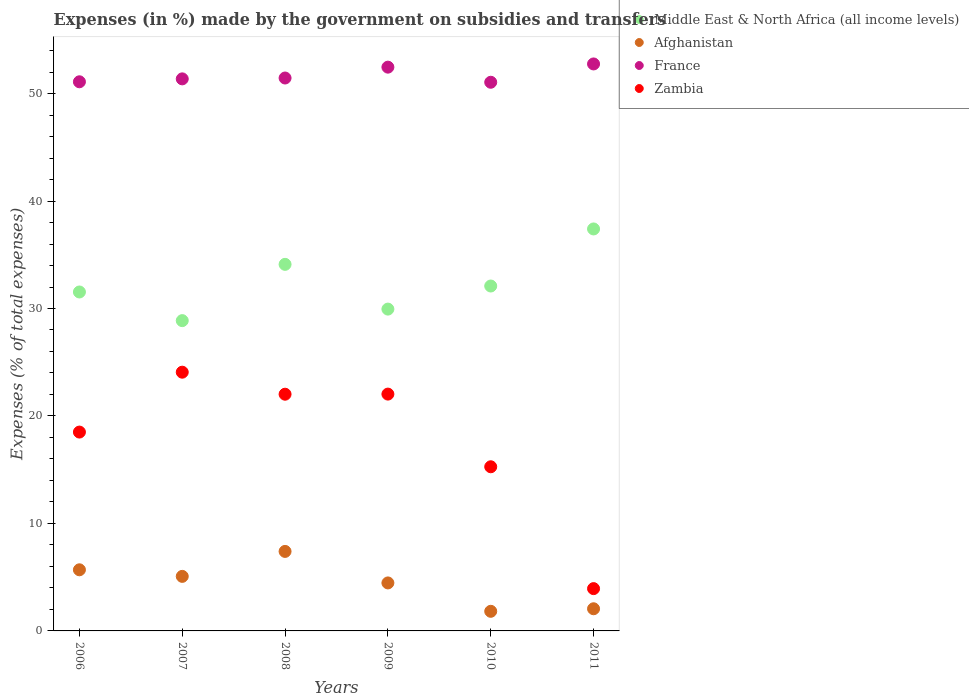How many different coloured dotlines are there?
Ensure brevity in your answer.  4. What is the percentage of expenses made by the government on subsidies and transfers in Zambia in 2008?
Your answer should be compact. 22.02. Across all years, what is the maximum percentage of expenses made by the government on subsidies and transfers in Zambia?
Offer a terse response. 24.07. Across all years, what is the minimum percentage of expenses made by the government on subsidies and transfers in Middle East & North Africa (all income levels)?
Offer a terse response. 28.87. In which year was the percentage of expenses made by the government on subsidies and transfers in Afghanistan maximum?
Provide a succinct answer. 2008. In which year was the percentage of expenses made by the government on subsidies and transfers in Zambia minimum?
Provide a short and direct response. 2011. What is the total percentage of expenses made by the government on subsidies and transfers in Middle East & North Africa (all income levels) in the graph?
Ensure brevity in your answer.  193.95. What is the difference between the percentage of expenses made by the government on subsidies and transfers in Zambia in 2006 and that in 2008?
Your answer should be compact. -3.52. What is the difference between the percentage of expenses made by the government on subsidies and transfers in Afghanistan in 2006 and the percentage of expenses made by the government on subsidies and transfers in Zambia in 2010?
Offer a terse response. -9.59. What is the average percentage of expenses made by the government on subsidies and transfers in Afghanistan per year?
Provide a short and direct response. 4.42. In the year 2006, what is the difference between the percentage of expenses made by the government on subsidies and transfers in Zambia and percentage of expenses made by the government on subsidies and transfers in France?
Make the answer very short. -32.59. What is the ratio of the percentage of expenses made by the government on subsidies and transfers in Zambia in 2009 to that in 2011?
Your answer should be compact. 5.6. Is the percentage of expenses made by the government on subsidies and transfers in Afghanistan in 2010 less than that in 2011?
Offer a very short reply. Yes. Is the difference between the percentage of expenses made by the government on subsidies and transfers in Zambia in 2006 and 2008 greater than the difference between the percentage of expenses made by the government on subsidies and transfers in France in 2006 and 2008?
Your answer should be compact. No. What is the difference between the highest and the second highest percentage of expenses made by the government on subsidies and transfers in France?
Provide a short and direct response. 0.3. What is the difference between the highest and the lowest percentage of expenses made by the government on subsidies and transfers in Afghanistan?
Offer a terse response. 5.57. Is it the case that in every year, the sum of the percentage of expenses made by the government on subsidies and transfers in Afghanistan and percentage of expenses made by the government on subsidies and transfers in France  is greater than the percentage of expenses made by the government on subsidies and transfers in Zambia?
Provide a short and direct response. Yes. Does the percentage of expenses made by the government on subsidies and transfers in Middle East & North Africa (all income levels) monotonically increase over the years?
Give a very brief answer. No. Is the percentage of expenses made by the government on subsidies and transfers in France strictly less than the percentage of expenses made by the government on subsidies and transfers in Middle East & North Africa (all income levels) over the years?
Provide a short and direct response. No. How many dotlines are there?
Your answer should be compact. 4. What is the difference between two consecutive major ticks on the Y-axis?
Offer a very short reply. 10. Are the values on the major ticks of Y-axis written in scientific E-notation?
Your answer should be very brief. No. Where does the legend appear in the graph?
Keep it short and to the point. Top right. How are the legend labels stacked?
Keep it short and to the point. Vertical. What is the title of the graph?
Offer a terse response. Expenses (in %) made by the government on subsidies and transfers. Does "Liberia" appear as one of the legend labels in the graph?
Your answer should be very brief. No. What is the label or title of the X-axis?
Your response must be concise. Years. What is the label or title of the Y-axis?
Your answer should be very brief. Expenses (% of total expenses). What is the Expenses (% of total expenses) in Middle East & North Africa (all income levels) in 2006?
Your answer should be very brief. 31.54. What is the Expenses (% of total expenses) of Afghanistan in 2006?
Keep it short and to the point. 5.69. What is the Expenses (% of total expenses) in France in 2006?
Provide a short and direct response. 51.09. What is the Expenses (% of total expenses) of Zambia in 2006?
Make the answer very short. 18.5. What is the Expenses (% of total expenses) in Middle East & North Africa (all income levels) in 2007?
Provide a short and direct response. 28.87. What is the Expenses (% of total expenses) in Afghanistan in 2007?
Provide a succinct answer. 5.08. What is the Expenses (% of total expenses) of France in 2007?
Your response must be concise. 51.37. What is the Expenses (% of total expenses) of Zambia in 2007?
Provide a short and direct response. 24.07. What is the Expenses (% of total expenses) in Middle East & North Africa (all income levels) in 2008?
Your answer should be compact. 34.11. What is the Expenses (% of total expenses) in Afghanistan in 2008?
Your answer should be very brief. 7.4. What is the Expenses (% of total expenses) of France in 2008?
Offer a very short reply. 51.45. What is the Expenses (% of total expenses) in Zambia in 2008?
Offer a very short reply. 22.02. What is the Expenses (% of total expenses) of Middle East & North Africa (all income levels) in 2009?
Give a very brief answer. 29.94. What is the Expenses (% of total expenses) in Afghanistan in 2009?
Make the answer very short. 4.47. What is the Expenses (% of total expenses) in France in 2009?
Provide a succinct answer. 52.46. What is the Expenses (% of total expenses) in Zambia in 2009?
Provide a short and direct response. 22.04. What is the Expenses (% of total expenses) of Middle East & North Africa (all income levels) in 2010?
Your answer should be compact. 32.09. What is the Expenses (% of total expenses) of Afghanistan in 2010?
Offer a very short reply. 1.82. What is the Expenses (% of total expenses) of France in 2010?
Your response must be concise. 51.05. What is the Expenses (% of total expenses) in Zambia in 2010?
Make the answer very short. 15.27. What is the Expenses (% of total expenses) in Middle East & North Africa (all income levels) in 2011?
Your response must be concise. 37.4. What is the Expenses (% of total expenses) in Afghanistan in 2011?
Offer a very short reply. 2.06. What is the Expenses (% of total expenses) of France in 2011?
Offer a terse response. 52.75. What is the Expenses (% of total expenses) in Zambia in 2011?
Offer a terse response. 3.94. Across all years, what is the maximum Expenses (% of total expenses) of Middle East & North Africa (all income levels)?
Make the answer very short. 37.4. Across all years, what is the maximum Expenses (% of total expenses) in Afghanistan?
Provide a short and direct response. 7.4. Across all years, what is the maximum Expenses (% of total expenses) of France?
Give a very brief answer. 52.75. Across all years, what is the maximum Expenses (% of total expenses) in Zambia?
Offer a terse response. 24.07. Across all years, what is the minimum Expenses (% of total expenses) in Middle East & North Africa (all income levels)?
Your response must be concise. 28.87. Across all years, what is the minimum Expenses (% of total expenses) of Afghanistan?
Offer a very short reply. 1.82. Across all years, what is the minimum Expenses (% of total expenses) in France?
Keep it short and to the point. 51.05. Across all years, what is the minimum Expenses (% of total expenses) of Zambia?
Your answer should be very brief. 3.94. What is the total Expenses (% of total expenses) in Middle East & North Africa (all income levels) in the graph?
Your response must be concise. 193.95. What is the total Expenses (% of total expenses) in Afghanistan in the graph?
Your answer should be compact. 26.51. What is the total Expenses (% of total expenses) in France in the graph?
Offer a terse response. 310.17. What is the total Expenses (% of total expenses) in Zambia in the graph?
Provide a succinct answer. 105.84. What is the difference between the Expenses (% of total expenses) in Middle East & North Africa (all income levels) in 2006 and that in 2007?
Make the answer very short. 2.67. What is the difference between the Expenses (% of total expenses) of Afghanistan in 2006 and that in 2007?
Offer a very short reply. 0.61. What is the difference between the Expenses (% of total expenses) in France in 2006 and that in 2007?
Your answer should be compact. -0.27. What is the difference between the Expenses (% of total expenses) in Zambia in 2006 and that in 2007?
Make the answer very short. -5.57. What is the difference between the Expenses (% of total expenses) in Middle East & North Africa (all income levels) in 2006 and that in 2008?
Provide a short and direct response. -2.57. What is the difference between the Expenses (% of total expenses) in Afghanistan in 2006 and that in 2008?
Provide a succinct answer. -1.71. What is the difference between the Expenses (% of total expenses) in France in 2006 and that in 2008?
Your answer should be compact. -0.35. What is the difference between the Expenses (% of total expenses) of Zambia in 2006 and that in 2008?
Offer a terse response. -3.52. What is the difference between the Expenses (% of total expenses) in Middle East & North Africa (all income levels) in 2006 and that in 2009?
Provide a short and direct response. 1.59. What is the difference between the Expenses (% of total expenses) of Afghanistan in 2006 and that in 2009?
Your response must be concise. 1.22. What is the difference between the Expenses (% of total expenses) of France in 2006 and that in 2009?
Give a very brief answer. -1.36. What is the difference between the Expenses (% of total expenses) of Zambia in 2006 and that in 2009?
Offer a very short reply. -3.53. What is the difference between the Expenses (% of total expenses) in Middle East & North Africa (all income levels) in 2006 and that in 2010?
Provide a short and direct response. -0.56. What is the difference between the Expenses (% of total expenses) of Afghanistan in 2006 and that in 2010?
Provide a short and direct response. 3.86. What is the difference between the Expenses (% of total expenses) of France in 2006 and that in 2010?
Your answer should be compact. 0.04. What is the difference between the Expenses (% of total expenses) in Zambia in 2006 and that in 2010?
Your answer should be compact. 3.23. What is the difference between the Expenses (% of total expenses) of Middle East & North Africa (all income levels) in 2006 and that in 2011?
Your response must be concise. -5.87. What is the difference between the Expenses (% of total expenses) of Afghanistan in 2006 and that in 2011?
Keep it short and to the point. 3.63. What is the difference between the Expenses (% of total expenses) in France in 2006 and that in 2011?
Make the answer very short. -1.66. What is the difference between the Expenses (% of total expenses) of Zambia in 2006 and that in 2011?
Offer a terse response. 14.57. What is the difference between the Expenses (% of total expenses) of Middle East & North Africa (all income levels) in 2007 and that in 2008?
Give a very brief answer. -5.24. What is the difference between the Expenses (% of total expenses) in Afghanistan in 2007 and that in 2008?
Provide a succinct answer. -2.32. What is the difference between the Expenses (% of total expenses) in France in 2007 and that in 2008?
Provide a short and direct response. -0.08. What is the difference between the Expenses (% of total expenses) of Zambia in 2007 and that in 2008?
Provide a succinct answer. 2.05. What is the difference between the Expenses (% of total expenses) of Middle East & North Africa (all income levels) in 2007 and that in 2009?
Provide a short and direct response. -1.07. What is the difference between the Expenses (% of total expenses) in Afghanistan in 2007 and that in 2009?
Your response must be concise. 0.61. What is the difference between the Expenses (% of total expenses) in France in 2007 and that in 2009?
Your answer should be compact. -1.09. What is the difference between the Expenses (% of total expenses) of Zambia in 2007 and that in 2009?
Give a very brief answer. 2.04. What is the difference between the Expenses (% of total expenses) of Middle East & North Africa (all income levels) in 2007 and that in 2010?
Ensure brevity in your answer.  -3.22. What is the difference between the Expenses (% of total expenses) of Afghanistan in 2007 and that in 2010?
Give a very brief answer. 3.25. What is the difference between the Expenses (% of total expenses) in France in 2007 and that in 2010?
Your response must be concise. 0.32. What is the difference between the Expenses (% of total expenses) in Zambia in 2007 and that in 2010?
Offer a very short reply. 8.8. What is the difference between the Expenses (% of total expenses) of Middle East & North Africa (all income levels) in 2007 and that in 2011?
Keep it short and to the point. -8.53. What is the difference between the Expenses (% of total expenses) in Afghanistan in 2007 and that in 2011?
Ensure brevity in your answer.  3.01. What is the difference between the Expenses (% of total expenses) in France in 2007 and that in 2011?
Ensure brevity in your answer.  -1.39. What is the difference between the Expenses (% of total expenses) of Zambia in 2007 and that in 2011?
Give a very brief answer. 20.14. What is the difference between the Expenses (% of total expenses) in Middle East & North Africa (all income levels) in 2008 and that in 2009?
Make the answer very short. 4.16. What is the difference between the Expenses (% of total expenses) in Afghanistan in 2008 and that in 2009?
Give a very brief answer. 2.93. What is the difference between the Expenses (% of total expenses) in France in 2008 and that in 2009?
Offer a very short reply. -1.01. What is the difference between the Expenses (% of total expenses) of Zambia in 2008 and that in 2009?
Ensure brevity in your answer.  -0.01. What is the difference between the Expenses (% of total expenses) of Middle East & North Africa (all income levels) in 2008 and that in 2010?
Give a very brief answer. 2.02. What is the difference between the Expenses (% of total expenses) in Afghanistan in 2008 and that in 2010?
Your answer should be very brief. 5.57. What is the difference between the Expenses (% of total expenses) in France in 2008 and that in 2010?
Offer a terse response. 0.4. What is the difference between the Expenses (% of total expenses) of Zambia in 2008 and that in 2010?
Your response must be concise. 6.75. What is the difference between the Expenses (% of total expenses) in Middle East & North Africa (all income levels) in 2008 and that in 2011?
Ensure brevity in your answer.  -3.29. What is the difference between the Expenses (% of total expenses) of Afghanistan in 2008 and that in 2011?
Your response must be concise. 5.34. What is the difference between the Expenses (% of total expenses) in France in 2008 and that in 2011?
Your answer should be compact. -1.31. What is the difference between the Expenses (% of total expenses) in Zambia in 2008 and that in 2011?
Ensure brevity in your answer.  18.09. What is the difference between the Expenses (% of total expenses) of Middle East & North Africa (all income levels) in 2009 and that in 2010?
Keep it short and to the point. -2.15. What is the difference between the Expenses (% of total expenses) in Afghanistan in 2009 and that in 2010?
Offer a terse response. 2.64. What is the difference between the Expenses (% of total expenses) in France in 2009 and that in 2010?
Provide a succinct answer. 1.41. What is the difference between the Expenses (% of total expenses) in Zambia in 2009 and that in 2010?
Your response must be concise. 6.76. What is the difference between the Expenses (% of total expenses) of Middle East & North Africa (all income levels) in 2009 and that in 2011?
Your answer should be compact. -7.46. What is the difference between the Expenses (% of total expenses) in Afghanistan in 2009 and that in 2011?
Give a very brief answer. 2.4. What is the difference between the Expenses (% of total expenses) in France in 2009 and that in 2011?
Provide a short and direct response. -0.3. What is the difference between the Expenses (% of total expenses) of Zambia in 2009 and that in 2011?
Your response must be concise. 18.1. What is the difference between the Expenses (% of total expenses) in Middle East & North Africa (all income levels) in 2010 and that in 2011?
Your answer should be compact. -5.31. What is the difference between the Expenses (% of total expenses) of Afghanistan in 2010 and that in 2011?
Your response must be concise. -0.24. What is the difference between the Expenses (% of total expenses) in France in 2010 and that in 2011?
Your answer should be compact. -1.7. What is the difference between the Expenses (% of total expenses) of Zambia in 2010 and that in 2011?
Keep it short and to the point. 11.34. What is the difference between the Expenses (% of total expenses) of Middle East & North Africa (all income levels) in 2006 and the Expenses (% of total expenses) of Afghanistan in 2007?
Ensure brevity in your answer.  26.46. What is the difference between the Expenses (% of total expenses) of Middle East & North Africa (all income levels) in 2006 and the Expenses (% of total expenses) of France in 2007?
Provide a short and direct response. -19.83. What is the difference between the Expenses (% of total expenses) in Middle East & North Africa (all income levels) in 2006 and the Expenses (% of total expenses) in Zambia in 2007?
Ensure brevity in your answer.  7.46. What is the difference between the Expenses (% of total expenses) in Afghanistan in 2006 and the Expenses (% of total expenses) in France in 2007?
Provide a succinct answer. -45.68. What is the difference between the Expenses (% of total expenses) in Afghanistan in 2006 and the Expenses (% of total expenses) in Zambia in 2007?
Provide a succinct answer. -18.39. What is the difference between the Expenses (% of total expenses) of France in 2006 and the Expenses (% of total expenses) of Zambia in 2007?
Your answer should be very brief. 27.02. What is the difference between the Expenses (% of total expenses) of Middle East & North Africa (all income levels) in 2006 and the Expenses (% of total expenses) of Afghanistan in 2008?
Offer a very short reply. 24.14. What is the difference between the Expenses (% of total expenses) of Middle East & North Africa (all income levels) in 2006 and the Expenses (% of total expenses) of France in 2008?
Provide a short and direct response. -19.91. What is the difference between the Expenses (% of total expenses) of Middle East & North Africa (all income levels) in 2006 and the Expenses (% of total expenses) of Zambia in 2008?
Your answer should be very brief. 9.51. What is the difference between the Expenses (% of total expenses) in Afghanistan in 2006 and the Expenses (% of total expenses) in France in 2008?
Your answer should be very brief. -45.76. What is the difference between the Expenses (% of total expenses) of Afghanistan in 2006 and the Expenses (% of total expenses) of Zambia in 2008?
Keep it short and to the point. -16.34. What is the difference between the Expenses (% of total expenses) of France in 2006 and the Expenses (% of total expenses) of Zambia in 2008?
Give a very brief answer. 29.07. What is the difference between the Expenses (% of total expenses) in Middle East & North Africa (all income levels) in 2006 and the Expenses (% of total expenses) in Afghanistan in 2009?
Your answer should be very brief. 27.07. What is the difference between the Expenses (% of total expenses) of Middle East & North Africa (all income levels) in 2006 and the Expenses (% of total expenses) of France in 2009?
Provide a succinct answer. -20.92. What is the difference between the Expenses (% of total expenses) of Middle East & North Africa (all income levels) in 2006 and the Expenses (% of total expenses) of Zambia in 2009?
Your answer should be very brief. 9.5. What is the difference between the Expenses (% of total expenses) of Afghanistan in 2006 and the Expenses (% of total expenses) of France in 2009?
Make the answer very short. -46.77. What is the difference between the Expenses (% of total expenses) in Afghanistan in 2006 and the Expenses (% of total expenses) in Zambia in 2009?
Ensure brevity in your answer.  -16.35. What is the difference between the Expenses (% of total expenses) in France in 2006 and the Expenses (% of total expenses) in Zambia in 2009?
Keep it short and to the point. 29.06. What is the difference between the Expenses (% of total expenses) in Middle East & North Africa (all income levels) in 2006 and the Expenses (% of total expenses) in Afghanistan in 2010?
Your answer should be compact. 29.71. What is the difference between the Expenses (% of total expenses) of Middle East & North Africa (all income levels) in 2006 and the Expenses (% of total expenses) of France in 2010?
Offer a terse response. -19.51. What is the difference between the Expenses (% of total expenses) in Middle East & North Africa (all income levels) in 2006 and the Expenses (% of total expenses) in Zambia in 2010?
Your response must be concise. 16.26. What is the difference between the Expenses (% of total expenses) of Afghanistan in 2006 and the Expenses (% of total expenses) of France in 2010?
Give a very brief answer. -45.36. What is the difference between the Expenses (% of total expenses) in Afghanistan in 2006 and the Expenses (% of total expenses) in Zambia in 2010?
Offer a terse response. -9.59. What is the difference between the Expenses (% of total expenses) of France in 2006 and the Expenses (% of total expenses) of Zambia in 2010?
Offer a very short reply. 35.82. What is the difference between the Expenses (% of total expenses) of Middle East & North Africa (all income levels) in 2006 and the Expenses (% of total expenses) of Afghanistan in 2011?
Offer a terse response. 29.47. What is the difference between the Expenses (% of total expenses) of Middle East & North Africa (all income levels) in 2006 and the Expenses (% of total expenses) of France in 2011?
Your answer should be compact. -21.22. What is the difference between the Expenses (% of total expenses) in Middle East & North Africa (all income levels) in 2006 and the Expenses (% of total expenses) in Zambia in 2011?
Offer a very short reply. 27.6. What is the difference between the Expenses (% of total expenses) of Afghanistan in 2006 and the Expenses (% of total expenses) of France in 2011?
Ensure brevity in your answer.  -47.07. What is the difference between the Expenses (% of total expenses) in Afghanistan in 2006 and the Expenses (% of total expenses) in Zambia in 2011?
Offer a very short reply. 1.75. What is the difference between the Expenses (% of total expenses) of France in 2006 and the Expenses (% of total expenses) of Zambia in 2011?
Provide a short and direct response. 47.16. What is the difference between the Expenses (% of total expenses) of Middle East & North Africa (all income levels) in 2007 and the Expenses (% of total expenses) of Afghanistan in 2008?
Your response must be concise. 21.47. What is the difference between the Expenses (% of total expenses) in Middle East & North Africa (all income levels) in 2007 and the Expenses (% of total expenses) in France in 2008?
Your answer should be very brief. -22.58. What is the difference between the Expenses (% of total expenses) in Middle East & North Africa (all income levels) in 2007 and the Expenses (% of total expenses) in Zambia in 2008?
Your answer should be very brief. 6.85. What is the difference between the Expenses (% of total expenses) of Afghanistan in 2007 and the Expenses (% of total expenses) of France in 2008?
Provide a succinct answer. -46.37. What is the difference between the Expenses (% of total expenses) of Afghanistan in 2007 and the Expenses (% of total expenses) of Zambia in 2008?
Your answer should be compact. -16.95. What is the difference between the Expenses (% of total expenses) in France in 2007 and the Expenses (% of total expenses) in Zambia in 2008?
Keep it short and to the point. 29.34. What is the difference between the Expenses (% of total expenses) of Middle East & North Africa (all income levels) in 2007 and the Expenses (% of total expenses) of Afghanistan in 2009?
Ensure brevity in your answer.  24.4. What is the difference between the Expenses (% of total expenses) of Middle East & North Africa (all income levels) in 2007 and the Expenses (% of total expenses) of France in 2009?
Your answer should be compact. -23.59. What is the difference between the Expenses (% of total expenses) in Middle East & North Africa (all income levels) in 2007 and the Expenses (% of total expenses) in Zambia in 2009?
Make the answer very short. 6.84. What is the difference between the Expenses (% of total expenses) of Afghanistan in 2007 and the Expenses (% of total expenses) of France in 2009?
Give a very brief answer. -47.38. What is the difference between the Expenses (% of total expenses) of Afghanistan in 2007 and the Expenses (% of total expenses) of Zambia in 2009?
Ensure brevity in your answer.  -16.96. What is the difference between the Expenses (% of total expenses) of France in 2007 and the Expenses (% of total expenses) of Zambia in 2009?
Make the answer very short. 29.33. What is the difference between the Expenses (% of total expenses) of Middle East & North Africa (all income levels) in 2007 and the Expenses (% of total expenses) of Afghanistan in 2010?
Keep it short and to the point. 27.05. What is the difference between the Expenses (% of total expenses) of Middle East & North Africa (all income levels) in 2007 and the Expenses (% of total expenses) of France in 2010?
Keep it short and to the point. -22.18. What is the difference between the Expenses (% of total expenses) of Middle East & North Africa (all income levels) in 2007 and the Expenses (% of total expenses) of Zambia in 2010?
Give a very brief answer. 13.6. What is the difference between the Expenses (% of total expenses) of Afghanistan in 2007 and the Expenses (% of total expenses) of France in 2010?
Provide a short and direct response. -45.98. What is the difference between the Expenses (% of total expenses) of Afghanistan in 2007 and the Expenses (% of total expenses) of Zambia in 2010?
Your answer should be very brief. -10.2. What is the difference between the Expenses (% of total expenses) of France in 2007 and the Expenses (% of total expenses) of Zambia in 2010?
Ensure brevity in your answer.  36.09. What is the difference between the Expenses (% of total expenses) of Middle East & North Africa (all income levels) in 2007 and the Expenses (% of total expenses) of Afghanistan in 2011?
Make the answer very short. 26.81. What is the difference between the Expenses (% of total expenses) in Middle East & North Africa (all income levels) in 2007 and the Expenses (% of total expenses) in France in 2011?
Provide a short and direct response. -23.88. What is the difference between the Expenses (% of total expenses) in Middle East & North Africa (all income levels) in 2007 and the Expenses (% of total expenses) in Zambia in 2011?
Give a very brief answer. 24.93. What is the difference between the Expenses (% of total expenses) in Afghanistan in 2007 and the Expenses (% of total expenses) in France in 2011?
Your response must be concise. -47.68. What is the difference between the Expenses (% of total expenses) of Afghanistan in 2007 and the Expenses (% of total expenses) of Zambia in 2011?
Offer a terse response. 1.14. What is the difference between the Expenses (% of total expenses) in France in 2007 and the Expenses (% of total expenses) in Zambia in 2011?
Offer a very short reply. 47.43. What is the difference between the Expenses (% of total expenses) of Middle East & North Africa (all income levels) in 2008 and the Expenses (% of total expenses) of Afghanistan in 2009?
Give a very brief answer. 29.64. What is the difference between the Expenses (% of total expenses) of Middle East & North Africa (all income levels) in 2008 and the Expenses (% of total expenses) of France in 2009?
Keep it short and to the point. -18.35. What is the difference between the Expenses (% of total expenses) of Middle East & North Africa (all income levels) in 2008 and the Expenses (% of total expenses) of Zambia in 2009?
Provide a succinct answer. 12.07. What is the difference between the Expenses (% of total expenses) of Afghanistan in 2008 and the Expenses (% of total expenses) of France in 2009?
Your answer should be very brief. -45.06. What is the difference between the Expenses (% of total expenses) of Afghanistan in 2008 and the Expenses (% of total expenses) of Zambia in 2009?
Ensure brevity in your answer.  -14.64. What is the difference between the Expenses (% of total expenses) in France in 2008 and the Expenses (% of total expenses) in Zambia in 2009?
Your answer should be very brief. 29.41. What is the difference between the Expenses (% of total expenses) in Middle East & North Africa (all income levels) in 2008 and the Expenses (% of total expenses) in Afghanistan in 2010?
Offer a very short reply. 32.28. What is the difference between the Expenses (% of total expenses) of Middle East & North Africa (all income levels) in 2008 and the Expenses (% of total expenses) of France in 2010?
Offer a terse response. -16.94. What is the difference between the Expenses (% of total expenses) of Middle East & North Africa (all income levels) in 2008 and the Expenses (% of total expenses) of Zambia in 2010?
Keep it short and to the point. 18.83. What is the difference between the Expenses (% of total expenses) in Afghanistan in 2008 and the Expenses (% of total expenses) in France in 2010?
Give a very brief answer. -43.65. What is the difference between the Expenses (% of total expenses) in Afghanistan in 2008 and the Expenses (% of total expenses) in Zambia in 2010?
Give a very brief answer. -7.88. What is the difference between the Expenses (% of total expenses) in France in 2008 and the Expenses (% of total expenses) in Zambia in 2010?
Your answer should be compact. 36.17. What is the difference between the Expenses (% of total expenses) of Middle East & North Africa (all income levels) in 2008 and the Expenses (% of total expenses) of Afghanistan in 2011?
Offer a very short reply. 32.05. What is the difference between the Expenses (% of total expenses) in Middle East & North Africa (all income levels) in 2008 and the Expenses (% of total expenses) in France in 2011?
Keep it short and to the point. -18.65. What is the difference between the Expenses (% of total expenses) in Middle East & North Africa (all income levels) in 2008 and the Expenses (% of total expenses) in Zambia in 2011?
Offer a very short reply. 30.17. What is the difference between the Expenses (% of total expenses) in Afghanistan in 2008 and the Expenses (% of total expenses) in France in 2011?
Keep it short and to the point. -45.36. What is the difference between the Expenses (% of total expenses) in Afghanistan in 2008 and the Expenses (% of total expenses) in Zambia in 2011?
Ensure brevity in your answer.  3.46. What is the difference between the Expenses (% of total expenses) of France in 2008 and the Expenses (% of total expenses) of Zambia in 2011?
Keep it short and to the point. 47.51. What is the difference between the Expenses (% of total expenses) in Middle East & North Africa (all income levels) in 2009 and the Expenses (% of total expenses) in Afghanistan in 2010?
Keep it short and to the point. 28.12. What is the difference between the Expenses (% of total expenses) in Middle East & North Africa (all income levels) in 2009 and the Expenses (% of total expenses) in France in 2010?
Provide a succinct answer. -21.11. What is the difference between the Expenses (% of total expenses) of Middle East & North Africa (all income levels) in 2009 and the Expenses (% of total expenses) of Zambia in 2010?
Your response must be concise. 14.67. What is the difference between the Expenses (% of total expenses) of Afghanistan in 2009 and the Expenses (% of total expenses) of France in 2010?
Ensure brevity in your answer.  -46.58. What is the difference between the Expenses (% of total expenses) in Afghanistan in 2009 and the Expenses (% of total expenses) in Zambia in 2010?
Ensure brevity in your answer.  -10.81. What is the difference between the Expenses (% of total expenses) of France in 2009 and the Expenses (% of total expenses) of Zambia in 2010?
Ensure brevity in your answer.  37.18. What is the difference between the Expenses (% of total expenses) of Middle East & North Africa (all income levels) in 2009 and the Expenses (% of total expenses) of Afghanistan in 2011?
Keep it short and to the point. 27.88. What is the difference between the Expenses (% of total expenses) of Middle East & North Africa (all income levels) in 2009 and the Expenses (% of total expenses) of France in 2011?
Provide a succinct answer. -22.81. What is the difference between the Expenses (% of total expenses) in Middle East & North Africa (all income levels) in 2009 and the Expenses (% of total expenses) in Zambia in 2011?
Give a very brief answer. 26.01. What is the difference between the Expenses (% of total expenses) of Afghanistan in 2009 and the Expenses (% of total expenses) of France in 2011?
Ensure brevity in your answer.  -48.29. What is the difference between the Expenses (% of total expenses) in Afghanistan in 2009 and the Expenses (% of total expenses) in Zambia in 2011?
Your response must be concise. 0.53. What is the difference between the Expenses (% of total expenses) of France in 2009 and the Expenses (% of total expenses) of Zambia in 2011?
Give a very brief answer. 48.52. What is the difference between the Expenses (% of total expenses) in Middle East & North Africa (all income levels) in 2010 and the Expenses (% of total expenses) in Afghanistan in 2011?
Keep it short and to the point. 30.03. What is the difference between the Expenses (% of total expenses) of Middle East & North Africa (all income levels) in 2010 and the Expenses (% of total expenses) of France in 2011?
Provide a short and direct response. -20.66. What is the difference between the Expenses (% of total expenses) of Middle East & North Africa (all income levels) in 2010 and the Expenses (% of total expenses) of Zambia in 2011?
Your answer should be very brief. 28.16. What is the difference between the Expenses (% of total expenses) of Afghanistan in 2010 and the Expenses (% of total expenses) of France in 2011?
Your answer should be compact. -50.93. What is the difference between the Expenses (% of total expenses) in Afghanistan in 2010 and the Expenses (% of total expenses) in Zambia in 2011?
Provide a succinct answer. -2.11. What is the difference between the Expenses (% of total expenses) in France in 2010 and the Expenses (% of total expenses) in Zambia in 2011?
Your answer should be very brief. 47.11. What is the average Expenses (% of total expenses) in Middle East & North Africa (all income levels) per year?
Your answer should be compact. 32.33. What is the average Expenses (% of total expenses) in Afghanistan per year?
Provide a succinct answer. 4.42. What is the average Expenses (% of total expenses) in France per year?
Your response must be concise. 51.69. What is the average Expenses (% of total expenses) of Zambia per year?
Keep it short and to the point. 17.64. In the year 2006, what is the difference between the Expenses (% of total expenses) of Middle East & North Africa (all income levels) and Expenses (% of total expenses) of Afghanistan?
Your answer should be compact. 25.85. In the year 2006, what is the difference between the Expenses (% of total expenses) in Middle East & North Africa (all income levels) and Expenses (% of total expenses) in France?
Provide a succinct answer. -19.56. In the year 2006, what is the difference between the Expenses (% of total expenses) of Middle East & North Africa (all income levels) and Expenses (% of total expenses) of Zambia?
Your response must be concise. 13.03. In the year 2006, what is the difference between the Expenses (% of total expenses) of Afghanistan and Expenses (% of total expenses) of France?
Give a very brief answer. -45.41. In the year 2006, what is the difference between the Expenses (% of total expenses) of Afghanistan and Expenses (% of total expenses) of Zambia?
Your response must be concise. -12.81. In the year 2006, what is the difference between the Expenses (% of total expenses) in France and Expenses (% of total expenses) in Zambia?
Give a very brief answer. 32.59. In the year 2007, what is the difference between the Expenses (% of total expenses) of Middle East & North Africa (all income levels) and Expenses (% of total expenses) of Afghanistan?
Provide a short and direct response. 23.8. In the year 2007, what is the difference between the Expenses (% of total expenses) of Middle East & North Africa (all income levels) and Expenses (% of total expenses) of France?
Offer a terse response. -22.5. In the year 2007, what is the difference between the Expenses (% of total expenses) in Middle East & North Africa (all income levels) and Expenses (% of total expenses) in Zambia?
Give a very brief answer. 4.8. In the year 2007, what is the difference between the Expenses (% of total expenses) of Afghanistan and Expenses (% of total expenses) of France?
Give a very brief answer. -46.29. In the year 2007, what is the difference between the Expenses (% of total expenses) of Afghanistan and Expenses (% of total expenses) of Zambia?
Your answer should be very brief. -19. In the year 2007, what is the difference between the Expenses (% of total expenses) in France and Expenses (% of total expenses) in Zambia?
Offer a terse response. 27.29. In the year 2008, what is the difference between the Expenses (% of total expenses) in Middle East & North Africa (all income levels) and Expenses (% of total expenses) in Afghanistan?
Make the answer very short. 26.71. In the year 2008, what is the difference between the Expenses (% of total expenses) of Middle East & North Africa (all income levels) and Expenses (% of total expenses) of France?
Your answer should be very brief. -17.34. In the year 2008, what is the difference between the Expenses (% of total expenses) in Middle East & North Africa (all income levels) and Expenses (% of total expenses) in Zambia?
Ensure brevity in your answer.  12.08. In the year 2008, what is the difference between the Expenses (% of total expenses) of Afghanistan and Expenses (% of total expenses) of France?
Offer a very short reply. -44.05. In the year 2008, what is the difference between the Expenses (% of total expenses) of Afghanistan and Expenses (% of total expenses) of Zambia?
Provide a succinct answer. -14.63. In the year 2008, what is the difference between the Expenses (% of total expenses) in France and Expenses (% of total expenses) in Zambia?
Offer a terse response. 29.42. In the year 2009, what is the difference between the Expenses (% of total expenses) of Middle East & North Africa (all income levels) and Expenses (% of total expenses) of Afghanistan?
Your answer should be very brief. 25.48. In the year 2009, what is the difference between the Expenses (% of total expenses) in Middle East & North Africa (all income levels) and Expenses (% of total expenses) in France?
Your answer should be very brief. -22.51. In the year 2009, what is the difference between the Expenses (% of total expenses) of Middle East & North Africa (all income levels) and Expenses (% of total expenses) of Zambia?
Keep it short and to the point. 7.91. In the year 2009, what is the difference between the Expenses (% of total expenses) in Afghanistan and Expenses (% of total expenses) in France?
Your answer should be compact. -47.99. In the year 2009, what is the difference between the Expenses (% of total expenses) of Afghanistan and Expenses (% of total expenses) of Zambia?
Offer a terse response. -17.57. In the year 2009, what is the difference between the Expenses (% of total expenses) in France and Expenses (% of total expenses) in Zambia?
Offer a very short reply. 30.42. In the year 2010, what is the difference between the Expenses (% of total expenses) in Middle East & North Africa (all income levels) and Expenses (% of total expenses) in Afghanistan?
Make the answer very short. 30.27. In the year 2010, what is the difference between the Expenses (% of total expenses) in Middle East & North Africa (all income levels) and Expenses (% of total expenses) in France?
Offer a terse response. -18.96. In the year 2010, what is the difference between the Expenses (% of total expenses) of Middle East & North Africa (all income levels) and Expenses (% of total expenses) of Zambia?
Provide a short and direct response. 16.82. In the year 2010, what is the difference between the Expenses (% of total expenses) in Afghanistan and Expenses (% of total expenses) in France?
Make the answer very short. -49.23. In the year 2010, what is the difference between the Expenses (% of total expenses) of Afghanistan and Expenses (% of total expenses) of Zambia?
Your answer should be compact. -13.45. In the year 2010, what is the difference between the Expenses (% of total expenses) of France and Expenses (% of total expenses) of Zambia?
Your answer should be very brief. 35.78. In the year 2011, what is the difference between the Expenses (% of total expenses) of Middle East & North Africa (all income levels) and Expenses (% of total expenses) of Afghanistan?
Make the answer very short. 35.34. In the year 2011, what is the difference between the Expenses (% of total expenses) in Middle East & North Africa (all income levels) and Expenses (% of total expenses) in France?
Give a very brief answer. -15.35. In the year 2011, what is the difference between the Expenses (% of total expenses) in Middle East & North Africa (all income levels) and Expenses (% of total expenses) in Zambia?
Keep it short and to the point. 33.47. In the year 2011, what is the difference between the Expenses (% of total expenses) in Afghanistan and Expenses (% of total expenses) in France?
Offer a terse response. -50.69. In the year 2011, what is the difference between the Expenses (% of total expenses) of Afghanistan and Expenses (% of total expenses) of Zambia?
Offer a very short reply. -1.87. In the year 2011, what is the difference between the Expenses (% of total expenses) of France and Expenses (% of total expenses) of Zambia?
Your response must be concise. 48.82. What is the ratio of the Expenses (% of total expenses) in Middle East & North Africa (all income levels) in 2006 to that in 2007?
Provide a short and direct response. 1.09. What is the ratio of the Expenses (% of total expenses) in Afghanistan in 2006 to that in 2007?
Keep it short and to the point. 1.12. What is the ratio of the Expenses (% of total expenses) of Zambia in 2006 to that in 2007?
Provide a succinct answer. 0.77. What is the ratio of the Expenses (% of total expenses) of Middle East & North Africa (all income levels) in 2006 to that in 2008?
Give a very brief answer. 0.92. What is the ratio of the Expenses (% of total expenses) in Afghanistan in 2006 to that in 2008?
Provide a succinct answer. 0.77. What is the ratio of the Expenses (% of total expenses) in Zambia in 2006 to that in 2008?
Your answer should be compact. 0.84. What is the ratio of the Expenses (% of total expenses) of Middle East & North Africa (all income levels) in 2006 to that in 2009?
Provide a succinct answer. 1.05. What is the ratio of the Expenses (% of total expenses) of Afghanistan in 2006 to that in 2009?
Give a very brief answer. 1.27. What is the ratio of the Expenses (% of total expenses) in France in 2006 to that in 2009?
Offer a terse response. 0.97. What is the ratio of the Expenses (% of total expenses) of Zambia in 2006 to that in 2009?
Offer a terse response. 0.84. What is the ratio of the Expenses (% of total expenses) in Middle East & North Africa (all income levels) in 2006 to that in 2010?
Provide a short and direct response. 0.98. What is the ratio of the Expenses (% of total expenses) in Afghanistan in 2006 to that in 2010?
Offer a very short reply. 3.12. What is the ratio of the Expenses (% of total expenses) in Zambia in 2006 to that in 2010?
Ensure brevity in your answer.  1.21. What is the ratio of the Expenses (% of total expenses) of Middle East & North Africa (all income levels) in 2006 to that in 2011?
Provide a succinct answer. 0.84. What is the ratio of the Expenses (% of total expenses) in Afghanistan in 2006 to that in 2011?
Provide a succinct answer. 2.76. What is the ratio of the Expenses (% of total expenses) in France in 2006 to that in 2011?
Your response must be concise. 0.97. What is the ratio of the Expenses (% of total expenses) of Zambia in 2006 to that in 2011?
Your answer should be compact. 4.7. What is the ratio of the Expenses (% of total expenses) of Middle East & North Africa (all income levels) in 2007 to that in 2008?
Provide a succinct answer. 0.85. What is the ratio of the Expenses (% of total expenses) in Afghanistan in 2007 to that in 2008?
Make the answer very short. 0.69. What is the ratio of the Expenses (% of total expenses) in Zambia in 2007 to that in 2008?
Offer a terse response. 1.09. What is the ratio of the Expenses (% of total expenses) of Middle East & North Africa (all income levels) in 2007 to that in 2009?
Your answer should be very brief. 0.96. What is the ratio of the Expenses (% of total expenses) in Afghanistan in 2007 to that in 2009?
Provide a succinct answer. 1.14. What is the ratio of the Expenses (% of total expenses) of France in 2007 to that in 2009?
Offer a very short reply. 0.98. What is the ratio of the Expenses (% of total expenses) of Zambia in 2007 to that in 2009?
Provide a succinct answer. 1.09. What is the ratio of the Expenses (% of total expenses) of Middle East & North Africa (all income levels) in 2007 to that in 2010?
Make the answer very short. 0.9. What is the ratio of the Expenses (% of total expenses) of Afghanistan in 2007 to that in 2010?
Your answer should be very brief. 2.78. What is the ratio of the Expenses (% of total expenses) of Zambia in 2007 to that in 2010?
Your answer should be compact. 1.58. What is the ratio of the Expenses (% of total expenses) of Middle East & North Africa (all income levels) in 2007 to that in 2011?
Keep it short and to the point. 0.77. What is the ratio of the Expenses (% of total expenses) of Afghanistan in 2007 to that in 2011?
Keep it short and to the point. 2.46. What is the ratio of the Expenses (% of total expenses) in France in 2007 to that in 2011?
Your response must be concise. 0.97. What is the ratio of the Expenses (% of total expenses) in Zambia in 2007 to that in 2011?
Your answer should be compact. 6.12. What is the ratio of the Expenses (% of total expenses) in Middle East & North Africa (all income levels) in 2008 to that in 2009?
Offer a very short reply. 1.14. What is the ratio of the Expenses (% of total expenses) of Afghanistan in 2008 to that in 2009?
Your answer should be very brief. 1.66. What is the ratio of the Expenses (% of total expenses) of France in 2008 to that in 2009?
Keep it short and to the point. 0.98. What is the ratio of the Expenses (% of total expenses) of Middle East & North Africa (all income levels) in 2008 to that in 2010?
Give a very brief answer. 1.06. What is the ratio of the Expenses (% of total expenses) of Afghanistan in 2008 to that in 2010?
Ensure brevity in your answer.  4.05. What is the ratio of the Expenses (% of total expenses) in France in 2008 to that in 2010?
Provide a short and direct response. 1.01. What is the ratio of the Expenses (% of total expenses) of Zambia in 2008 to that in 2010?
Your answer should be very brief. 1.44. What is the ratio of the Expenses (% of total expenses) of Middle East & North Africa (all income levels) in 2008 to that in 2011?
Offer a very short reply. 0.91. What is the ratio of the Expenses (% of total expenses) of Afghanistan in 2008 to that in 2011?
Offer a terse response. 3.59. What is the ratio of the Expenses (% of total expenses) in France in 2008 to that in 2011?
Provide a succinct answer. 0.98. What is the ratio of the Expenses (% of total expenses) of Zambia in 2008 to that in 2011?
Offer a very short reply. 5.6. What is the ratio of the Expenses (% of total expenses) of Middle East & North Africa (all income levels) in 2009 to that in 2010?
Ensure brevity in your answer.  0.93. What is the ratio of the Expenses (% of total expenses) of Afghanistan in 2009 to that in 2010?
Provide a succinct answer. 2.45. What is the ratio of the Expenses (% of total expenses) of France in 2009 to that in 2010?
Your answer should be compact. 1.03. What is the ratio of the Expenses (% of total expenses) of Zambia in 2009 to that in 2010?
Make the answer very short. 1.44. What is the ratio of the Expenses (% of total expenses) of Middle East & North Africa (all income levels) in 2009 to that in 2011?
Provide a succinct answer. 0.8. What is the ratio of the Expenses (% of total expenses) in Afghanistan in 2009 to that in 2011?
Provide a short and direct response. 2.17. What is the ratio of the Expenses (% of total expenses) in Zambia in 2009 to that in 2011?
Your response must be concise. 5.6. What is the ratio of the Expenses (% of total expenses) in Middle East & North Africa (all income levels) in 2010 to that in 2011?
Give a very brief answer. 0.86. What is the ratio of the Expenses (% of total expenses) in Afghanistan in 2010 to that in 2011?
Your answer should be compact. 0.89. What is the ratio of the Expenses (% of total expenses) of Zambia in 2010 to that in 2011?
Provide a short and direct response. 3.88. What is the difference between the highest and the second highest Expenses (% of total expenses) in Middle East & North Africa (all income levels)?
Make the answer very short. 3.29. What is the difference between the highest and the second highest Expenses (% of total expenses) of Afghanistan?
Your answer should be very brief. 1.71. What is the difference between the highest and the second highest Expenses (% of total expenses) of France?
Make the answer very short. 0.3. What is the difference between the highest and the second highest Expenses (% of total expenses) in Zambia?
Keep it short and to the point. 2.04. What is the difference between the highest and the lowest Expenses (% of total expenses) in Middle East & North Africa (all income levels)?
Provide a succinct answer. 8.53. What is the difference between the highest and the lowest Expenses (% of total expenses) in Afghanistan?
Your answer should be compact. 5.57. What is the difference between the highest and the lowest Expenses (% of total expenses) of France?
Make the answer very short. 1.7. What is the difference between the highest and the lowest Expenses (% of total expenses) of Zambia?
Your answer should be very brief. 20.14. 